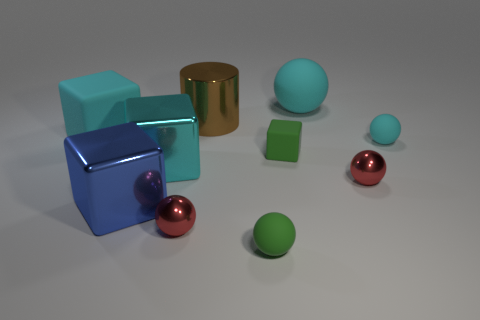Is there any other thing that is the same size as the brown metallic cylinder?
Provide a succinct answer. Yes. Is the size of the cylinder the same as the green matte sphere?
Your answer should be very brief. No. Are there any other things of the same color as the small cube?
Offer a very short reply. Yes. There is a metal thing that is both to the right of the large cyan metal thing and left of the brown cylinder; what shape is it?
Offer a terse response. Sphere. There is a matte block behind the small cyan matte object; what size is it?
Give a very brief answer. Large. There is a cyan ball that is to the left of the small metallic sphere to the right of the large matte sphere; what number of blue shiny objects are in front of it?
Your response must be concise. 1. Are there any blue things in front of the blue shiny thing?
Keep it short and to the point. No. What number of other objects are there of the same size as the metallic cylinder?
Offer a terse response. 4. There is a cyan thing that is both behind the tiny green matte cube and to the left of the small green cube; what is its material?
Provide a short and direct response. Rubber. Do the brown thing that is behind the green rubber ball and the big matte thing left of the tiny green sphere have the same shape?
Make the answer very short. No. 